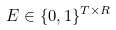<formula> <loc_0><loc_0><loc_500><loc_500>E \in \{ 0 , 1 \} ^ { T \times R }</formula> 